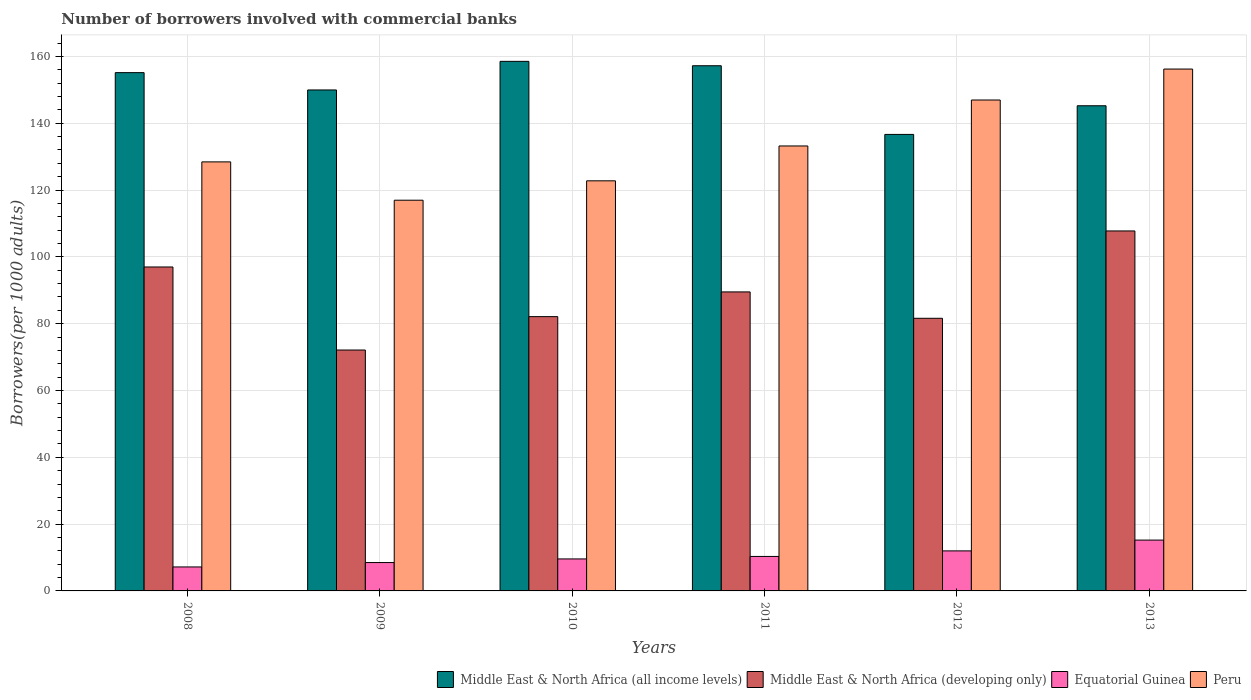How many groups of bars are there?
Ensure brevity in your answer.  6. What is the number of borrowers involved with commercial banks in Peru in 2012?
Ensure brevity in your answer.  146.94. Across all years, what is the maximum number of borrowers involved with commercial banks in Peru?
Provide a succinct answer. 156.21. Across all years, what is the minimum number of borrowers involved with commercial banks in Middle East & North Africa (all income levels)?
Provide a short and direct response. 136.65. What is the total number of borrowers involved with commercial banks in Middle East & North Africa (all income levels) in the graph?
Your answer should be very brief. 902.66. What is the difference between the number of borrowers involved with commercial banks in Peru in 2009 and that in 2011?
Provide a succinct answer. -16.24. What is the difference between the number of borrowers involved with commercial banks in Peru in 2011 and the number of borrowers involved with commercial banks in Equatorial Guinea in 2012?
Provide a succinct answer. 121.2. What is the average number of borrowers involved with commercial banks in Equatorial Guinea per year?
Your response must be concise. 10.46. In the year 2013, what is the difference between the number of borrowers involved with commercial banks in Peru and number of borrowers involved with commercial banks in Middle East & North Africa (all income levels)?
Offer a terse response. 10.99. What is the ratio of the number of borrowers involved with commercial banks in Middle East & North Africa (developing only) in 2011 to that in 2012?
Offer a terse response. 1.1. Is the number of borrowers involved with commercial banks in Equatorial Guinea in 2011 less than that in 2012?
Keep it short and to the point. Yes. Is the difference between the number of borrowers involved with commercial banks in Peru in 2011 and 2013 greater than the difference between the number of borrowers involved with commercial banks in Middle East & North Africa (all income levels) in 2011 and 2013?
Ensure brevity in your answer.  No. What is the difference between the highest and the second highest number of borrowers involved with commercial banks in Peru?
Give a very brief answer. 9.27. What is the difference between the highest and the lowest number of borrowers involved with commercial banks in Peru?
Ensure brevity in your answer.  39.26. In how many years, is the number of borrowers involved with commercial banks in Peru greater than the average number of borrowers involved with commercial banks in Peru taken over all years?
Offer a terse response. 2. Is the sum of the number of borrowers involved with commercial banks in Middle East & North Africa (developing only) in 2009 and 2011 greater than the maximum number of borrowers involved with commercial banks in Middle East & North Africa (all income levels) across all years?
Offer a very short reply. Yes. Is it the case that in every year, the sum of the number of borrowers involved with commercial banks in Equatorial Guinea and number of borrowers involved with commercial banks in Middle East & North Africa (all income levels) is greater than the sum of number of borrowers involved with commercial banks in Middle East & North Africa (developing only) and number of borrowers involved with commercial banks in Peru?
Your response must be concise. No. What does the 2nd bar from the left in 2010 represents?
Your response must be concise. Middle East & North Africa (developing only). What does the 3rd bar from the right in 2009 represents?
Your answer should be very brief. Middle East & North Africa (developing only). How many bars are there?
Provide a succinct answer. 24. How many years are there in the graph?
Your answer should be compact. 6. What is the difference between two consecutive major ticks on the Y-axis?
Give a very brief answer. 20. Are the values on the major ticks of Y-axis written in scientific E-notation?
Your response must be concise. No. Does the graph contain any zero values?
Give a very brief answer. No. How many legend labels are there?
Ensure brevity in your answer.  4. What is the title of the graph?
Keep it short and to the point. Number of borrowers involved with commercial banks. Does "Liechtenstein" appear as one of the legend labels in the graph?
Make the answer very short. No. What is the label or title of the Y-axis?
Your response must be concise. Borrowers(per 1000 adults). What is the Borrowers(per 1000 adults) of Middle East & North Africa (all income levels) in 2008?
Offer a very short reply. 155.14. What is the Borrowers(per 1000 adults) in Middle East & North Africa (developing only) in 2008?
Make the answer very short. 96.96. What is the Borrowers(per 1000 adults) in Equatorial Guinea in 2008?
Offer a very short reply. 7.17. What is the Borrowers(per 1000 adults) in Peru in 2008?
Make the answer very short. 128.42. What is the Borrowers(per 1000 adults) in Middle East & North Africa (all income levels) in 2009?
Your answer should be compact. 149.95. What is the Borrowers(per 1000 adults) of Middle East & North Africa (developing only) in 2009?
Your answer should be very brief. 72.11. What is the Borrowers(per 1000 adults) in Equatorial Guinea in 2009?
Your response must be concise. 8.49. What is the Borrowers(per 1000 adults) of Peru in 2009?
Give a very brief answer. 116.95. What is the Borrowers(per 1000 adults) of Middle East & North Africa (all income levels) in 2010?
Your response must be concise. 158.51. What is the Borrowers(per 1000 adults) of Middle East & North Africa (developing only) in 2010?
Provide a short and direct response. 82.1. What is the Borrowers(per 1000 adults) in Equatorial Guinea in 2010?
Provide a succinct answer. 9.58. What is the Borrowers(per 1000 adults) of Peru in 2010?
Provide a succinct answer. 122.75. What is the Borrowers(per 1000 adults) of Middle East & North Africa (all income levels) in 2011?
Give a very brief answer. 157.2. What is the Borrowers(per 1000 adults) in Middle East & North Africa (developing only) in 2011?
Your answer should be very brief. 89.5. What is the Borrowers(per 1000 adults) of Equatorial Guinea in 2011?
Your answer should be compact. 10.32. What is the Borrowers(per 1000 adults) of Peru in 2011?
Give a very brief answer. 133.19. What is the Borrowers(per 1000 adults) of Middle East & North Africa (all income levels) in 2012?
Provide a short and direct response. 136.65. What is the Borrowers(per 1000 adults) in Middle East & North Africa (developing only) in 2012?
Offer a very short reply. 81.61. What is the Borrowers(per 1000 adults) in Equatorial Guinea in 2012?
Your response must be concise. 11.98. What is the Borrowers(per 1000 adults) in Peru in 2012?
Your answer should be very brief. 146.94. What is the Borrowers(per 1000 adults) of Middle East & North Africa (all income levels) in 2013?
Provide a short and direct response. 145.22. What is the Borrowers(per 1000 adults) of Middle East & North Africa (developing only) in 2013?
Keep it short and to the point. 107.75. What is the Borrowers(per 1000 adults) in Equatorial Guinea in 2013?
Give a very brief answer. 15.22. What is the Borrowers(per 1000 adults) of Peru in 2013?
Provide a short and direct response. 156.21. Across all years, what is the maximum Borrowers(per 1000 adults) of Middle East & North Africa (all income levels)?
Give a very brief answer. 158.51. Across all years, what is the maximum Borrowers(per 1000 adults) in Middle East & North Africa (developing only)?
Your answer should be very brief. 107.75. Across all years, what is the maximum Borrowers(per 1000 adults) in Equatorial Guinea?
Make the answer very short. 15.22. Across all years, what is the maximum Borrowers(per 1000 adults) of Peru?
Your response must be concise. 156.21. Across all years, what is the minimum Borrowers(per 1000 adults) of Middle East & North Africa (all income levels)?
Provide a succinct answer. 136.65. Across all years, what is the minimum Borrowers(per 1000 adults) of Middle East & North Africa (developing only)?
Provide a short and direct response. 72.11. Across all years, what is the minimum Borrowers(per 1000 adults) of Equatorial Guinea?
Your answer should be compact. 7.17. Across all years, what is the minimum Borrowers(per 1000 adults) of Peru?
Offer a very short reply. 116.95. What is the total Borrowers(per 1000 adults) in Middle East & North Africa (all income levels) in the graph?
Ensure brevity in your answer.  902.66. What is the total Borrowers(per 1000 adults) in Middle East & North Africa (developing only) in the graph?
Offer a terse response. 530.03. What is the total Borrowers(per 1000 adults) in Equatorial Guinea in the graph?
Offer a terse response. 62.76. What is the total Borrowers(per 1000 adults) of Peru in the graph?
Offer a very short reply. 804.46. What is the difference between the Borrowers(per 1000 adults) in Middle East & North Africa (all income levels) in 2008 and that in 2009?
Your answer should be compact. 5.19. What is the difference between the Borrowers(per 1000 adults) of Middle East & North Africa (developing only) in 2008 and that in 2009?
Your answer should be very brief. 24.86. What is the difference between the Borrowers(per 1000 adults) of Equatorial Guinea in 2008 and that in 2009?
Give a very brief answer. -1.31. What is the difference between the Borrowers(per 1000 adults) in Peru in 2008 and that in 2009?
Your answer should be compact. 11.47. What is the difference between the Borrowers(per 1000 adults) in Middle East & North Africa (all income levels) in 2008 and that in 2010?
Keep it short and to the point. -3.38. What is the difference between the Borrowers(per 1000 adults) in Middle East & North Africa (developing only) in 2008 and that in 2010?
Give a very brief answer. 14.86. What is the difference between the Borrowers(per 1000 adults) of Equatorial Guinea in 2008 and that in 2010?
Provide a succinct answer. -2.4. What is the difference between the Borrowers(per 1000 adults) in Peru in 2008 and that in 2010?
Offer a terse response. 5.67. What is the difference between the Borrowers(per 1000 adults) in Middle East & North Africa (all income levels) in 2008 and that in 2011?
Your response must be concise. -2.06. What is the difference between the Borrowers(per 1000 adults) in Middle East & North Africa (developing only) in 2008 and that in 2011?
Your answer should be very brief. 7.46. What is the difference between the Borrowers(per 1000 adults) in Equatorial Guinea in 2008 and that in 2011?
Offer a very short reply. -3.14. What is the difference between the Borrowers(per 1000 adults) of Peru in 2008 and that in 2011?
Your answer should be compact. -4.77. What is the difference between the Borrowers(per 1000 adults) in Middle East & North Africa (all income levels) in 2008 and that in 2012?
Give a very brief answer. 18.49. What is the difference between the Borrowers(per 1000 adults) in Middle East & North Africa (developing only) in 2008 and that in 2012?
Keep it short and to the point. 15.36. What is the difference between the Borrowers(per 1000 adults) in Equatorial Guinea in 2008 and that in 2012?
Provide a short and direct response. -4.81. What is the difference between the Borrowers(per 1000 adults) of Peru in 2008 and that in 2012?
Make the answer very short. -18.52. What is the difference between the Borrowers(per 1000 adults) of Middle East & North Africa (all income levels) in 2008 and that in 2013?
Give a very brief answer. 9.91. What is the difference between the Borrowers(per 1000 adults) of Middle East & North Africa (developing only) in 2008 and that in 2013?
Keep it short and to the point. -10.79. What is the difference between the Borrowers(per 1000 adults) in Equatorial Guinea in 2008 and that in 2013?
Give a very brief answer. -8.04. What is the difference between the Borrowers(per 1000 adults) in Peru in 2008 and that in 2013?
Make the answer very short. -27.79. What is the difference between the Borrowers(per 1000 adults) of Middle East & North Africa (all income levels) in 2009 and that in 2010?
Offer a very short reply. -8.56. What is the difference between the Borrowers(per 1000 adults) in Middle East & North Africa (developing only) in 2009 and that in 2010?
Your answer should be very brief. -10. What is the difference between the Borrowers(per 1000 adults) of Equatorial Guinea in 2009 and that in 2010?
Your answer should be compact. -1.09. What is the difference between the Borrowers(per 1000 adults) of Peru in 2009 and that in 2010?
Make the answer very short. -5.8. What is the difference between the Borrowers(per 1000 adults) in Middle East & North Africa (all income levels) in 2009 and that in 2011?
Your response must be concise. -7.25. What is the difference between the Borrowers(per 1000 adults) in Middle East & North Africa (developing only) in 2009 and that in 2011?
Keep it short and to the point. -17.4. What is the difference between the Borrowers(per 1000 adults) of Equatorial Guinea in 2009 and that in 2011?
Your response must be concise. -1.83. What is the difference between the Borrowers(per 1000 adults) of Peru in 2009 and that in 2011?
Provide a succinct answer. -16.24. What is the difference between the Borrowers(per 1000 adults) in Middle East & North Africa (all income levels) in 2009 and that in 2012?
Keep it short and to the point. 13.3. What is the difference between the Borrowers(per 1000 adults) of Middle East & North Africa (developing only) in 2009 and that in 2012?
Ensure brevity in your answer.  -9.5. What is the difference between the Borrowers(per 1000 adults) of Equatorial Guinea in 2009 and that in 2012?
Provide a short and direct response. -3.5. What is the difference between the Borrowers(per 1000 adults) in Peru in 2009 and that in 2012?
Your answer should be compact. -29.99. What is the difference between the Borrowers(per 1000 adults) of Middle East & North Africa (all income levels) in 2009 and that in 2013?
Give a very brief answer. 4.73. What is the difference between the Borrowers(per 1000 adults) of Middle East & North Africa (developing only) in 2009 and that in 2013?
Keep it short and to the point. -35.65. What is the difference between the Borrowers(per 1000 adults) of Equatorial Guinea in 2009 and that in 2013?
Ensure brevity in your answer.  -6.73. What is the difference between the Borrowers(per 1000 adults) in Peru in 2009 and that in 2013?
Give a very brief answer. -39.26. What is the difference between the Borrowers(per 1000 adults) of Middle East & North Africa (all income levels) in 2010 and that in 2011?
Make the answer very short. 1.32. What is the difference between the Borrowers(per 1000 adults) in Middle East & North Africa (developing only) in 2010 and that in 2011?
Make the answer very short. -7.4. What is the difference between the Borrowers(per 1000 adults) of Equatorial Guinea in 2010 and that in 2011?
Your answer should be compact. -0.74. What is the difference between the Borrowers(per 1000 adults) in Peru in 2010 and that in 2011?
Ensure brevity in your answer.  -10.43. What is the difference between the Borrowers(per 1000 adults) of Middle East & North Africa (all income levels) in 2010 and that in 2012?
Offer a very short reply. 21.87. What is the difference between the Borrowers(per 1000 adults) in Middle East & North Africa (developing only) in 2010 and that in 2012?
Give a very brief answer. 0.5. What is the difference between the Borrowers(per 1000 adults) of Equatorial Guinea in 2010 and that in 2012?
Offer a terse response. -2.41. What is the difference between the Borrowers(per 1000 adults) of Peru in 2010 and that in 2012?
Your answer should be compact. -24.19. What is the difference between the Borrowers(per 1000 adults) of Middle East & North Africa (all income levels) in 2010 and that in 2013?
Make the answer very short. 13.29. What is the difference between the Borrowers(per 1000 adults) of Middle East & North Africa (developing only) in 2010 and that in 2013?
Offer a terse response. -25.65. What is the difference between the Borrowers(per 1000 adults) of Equatorial Guinea in 2010 and that in 2013?
Make the answer very short. -5.64. What is the difference between the Borrowers(per 1000 adults) in Peru in 2010 and that in 2013?
Your answer should be very brief. -33.46. What is the difference between the Borrowers(per 1000 adults) in Middle East & North Africa (all income levels) in 2011 and that in 2012?
Your response must be concise. 20.55. What is the difference between the Borrowers(per 1000 adults) of Middle East & North Africa (developing only) in 2011 and that in 2012?
Make the answer very short. 7.9. What is the difference between the Borrowers(per 1000 adults) of Equatorial Guinea in 2011 and that in 2012?
Your answer should be very brief. -1.67. What is the difference between the Borrowers(per 1000 adults) in Peru in 2011 and that in 2012?
Your answer should be very brief. -13.75. What is the difference between the Borrowers(per 1000 adults) in Middle East & North Africa (all income levels) in 2011 and that in 2013?
Offer a very short reply. 11.98. What is the difference between the Borrowers(per 1000 adults) of Middle East & North Africa (developing only) in 2011 and that in 2013?
Make the answer very short. -18.25. What is the difference between the Borrowers(per 1000 adults) in Equatorial Guinea in 2011 and that in 2013?
Your response must be concise. -4.9. What is the difference between the Borrowers(per 1000 adults) of Peru in 2011 and that in 2013?
Your answer should be very brief. -23.02. What is the difference between the Borrowers(per 1000 adults) in Middle East & North Africa (all income levels) in 2012 and that in 2013?
Ensure brevity in your answer.  -8.58. What is the difference between the Borrowers(per 1000 adults) of Middle East & North Africa (developing only) in 2012 and that in 2013?
Provide a short and direct response. -26.15. What is the difference between the Borrowers(per 1000 adults) in Equatorial Guinea in 2012 and that in 2013?
Keep it short and to the point. -3.23. What is the difference between the Borrowers(per 1000 adults) in Peru in 2012 and that in 2013?
Offer a very short reply. -9.27. What is the difference between the Borrowers(per 1000 adults) in Middle East & North Africa (all income levels) in 2008 and the Borrowers(per 1000 adults) in Middle East & North Africa (developing only) in 2009?
Offer a terse response. 83.03. What is the difference between the Borrowers(per 1000 adults) in Middle East & North Africa (all income levels) in 2008 and the Borrowers(per 1000 adults) in Equatorial Guinea in 2009?
Ensure brevity in your answer.  146.65. What is the difference between the Borrowers(per 1000 adults) of Middle East & North Africa (all income levels) in 2008 and the Borrowers(per 1000 adults) of Peru in 2009?
Offer a terse response. 38.18. What is the difference between the Borrowers(per 1000 adults) in Middle East & North Africa (developing only) in 2008 and the Borrowers(per 1000 adults) in Equatorial Guinea in 2009?
Make the answer very short. 88.47. What is the difference between the Borrowers(per 1000 adults) in Middle East & North Africa (developing only) in 2008 and the Borrowers(per 1000 adults) in Peru in 2009?
Make the answer very short. -19.99. What is the difference between the Borrowers(per 1000 adults) of Equatorial Guinea in 2008 and the Borrowers(per 1000 adults) of Peru in 2009?
Provide a succinct answer. -109.78. What is the difference between the Borrowers(per 1000 adults) of Middle East & North Africa (all income levels) in 2008 and the Borrowers(per 1000 adults) of Middle East & North Africa (developing only) in 2010?
Provide a short and direct response. 73.03. What is the difference between the Borrowers(per 1000 adults) of Middle East & North Africa (all income levels) in 2008 and the Borrowers(per 1000 adults) of Equatorial Guinea in 2010?
Provide a succinct answer. 145.56. What is the difference between the Borrowers(per 1000 adults) of Middle East & North Africa (all income levels) in 2008 and the Borrowers(per 1000 adults) of Peru in 2010?
Give a very brief answer. 32.38. What is the difference between the Borrowers(per 1000 adults) in Middle East & North Africa (developing only) in 2008 and the Borrowers(per 1000 adults) in Equatorial Guinea in 2010?
Keep it short and to the point. 87.39. What is the difference between the Borrowers(per 1000 adults) in Middle East & North Africa (developing only) in 2008 and the Borrowers(per 1000 adults) in Peru in 2010?
Make the answer very short. -25.79. What is the difference between the Borrowers(per 1000 adults) in Equatorial Guinea in 2008 and the Borrowers(per 1000 adults) in Peru in 2010?
Your response must be concise. -115.58. What is the difference between the Borrowers(per 1000 adults) in Middle East & North Africa (all income levels) in 2008 and the Borrowers(per 1000 adults) in Middle East & North Africa (developing only) in 2011?
Make the answer very short. 65.63. What is the difference between the Borrowers(per 1000 adults) of Middle East & North Africa (all income levels) in 2008 and the Borrowers(per 1000 adults) of Equatorial Guinea in 2011?
Keep it short and to the point. 144.82. What is the difference between the Borrowers(per 1000 adults) in Middle East & North Africa (all income levels) in 2008 and the Borrowers(per 1000 adults) in Peru in 2011?
Your answer should be compact. 21.95. What is the difference between the Borrowers(per 1000 adults) in Middle East & North Africa (developing only) in 2008 and the Borrowers(per 1000 adults) in Equatorial Guinea in 2011?
Your response must be concise. 86.65. What is the difference between the Borrowers(per 1000 adults) in Middle East & North Africa (developing only) in 2008 and the Borrowers(per 1000 adults) in Peru in 2011?
Your response must be concise. -36.22. What is the difference between the Borrowers(per 1000 adults) of Equatorial Guinea in 2008 and the Borrowers(per 1000 adults) of Peru in 2011?
Give a very brief answer. -126.01. What is the difference between the Borrowers(per 1000 adults) in Middle East & North Africa (all income levels) in 2008 and the Borrowers(per 1000 adults) in Middle East & North Africa (developing only) in 2012?
Make the answer very short. 73.53. What is the difference between the Borrowers(per 1000 adults) in Middle East & North Africa (all income levels) in 2008 and the Borrowers(per 1000 adults) in Equatorial Guinea in 2012?
Your answer should be very brief. 143.15. What is the difference between the Borrowers(per 1000 adults) of Middle East & North Africa (all income levels) in 2008 and the Borrowers(per 1000 adults) of Peru in 2012?
Keep it short and to the point. 8.19. What is the difference between the Borrowers(per 1000 adults) of Middle East & North Africa (developing only) in 2008 and the Borrowers(per 1000 adults) of Equatorial Guinea in 2012?
Offer a very short reply. 84.98. What is the difference between the Borrowers(per 1000 adults) in Middle East & North Africa (developing only) in 2008 and the Borrowers(per 1000 adults) in Peru in 2012?
Make the answer very short. -49.98. What is the difference between the Borrowers(per 1000 adults) in Equatorial Guinea in 2008 and the Borrowers(per 1000 adults) in Peru in 2012?
Give a very brief answer. -139.77. What is the difference between the Borrowers(per 1000 adults) of Middle East & North Africa (all income levels) in 2008 and the Borrowers(per 1000 adults) of Middle East & North Africa (developing only) in 2013?
Provide a short and direct response. 47.38. What is the difference between the Borrowers(per 1000 adults) in Middle East & North Africa (all income levels) in 2008 and the Borrowers(per 1000 adults) in Equatorial Guinea in 2013?
Give a very brief answer. 139.92. What is the difference between the Borrowers(per 1000 adults) of Middle East & North Africa (all income levels) in 2008 and the Borrowers(per 1000 adults) of Peru in 2013?
Your response must be concise. -1.07. What is the difference between the Borrowers(per 1000 adults) of Middle East & North Africa (developing only) in 2008 and the Borrowers(per 1000 adults) of Equatorial Guinea in 2013?
Give a very brief answer. 81.75. What is the difference between the Borrowers(per 1000 adults) of Middle East & North Africa (developing only) in 2008 and the Borrowers(per 1000 adults) of Peru in 2013?
Give a very brief answer. -59.25. What is the difference between the Borrowers(per 1000 adults) of Equatorial Guinea in 2008 and the Borrowers(per 1000 adults) of Peru in 2013?
Your response must be concise. -149.04. What is the difference between the Borrowers(per 1000 adults) in Middle East & North Africa (all income levels) in 2009 and the Borrowers(per 1000 adults) in Middle East & North Africa (developing only) in 2010?
Offer a very short reply. 67.85. What is the difference between the Borrowers(per 1000 adults) in Middle East & North Africa (all income levels) in 2009 and the Borrowers(per 1000 adults) in Equatorial Guinea in 2010?
Your response must be concise. 140.37. What is the difference between the Borrowers(per 1000 adults) in Middle East & North Africa (all income levels) in 2009 and the Borrowers(per 1000 adults) in Peru in 2010?
Make the answer very short. 27.2. What is the difference between the Borrowers(per 1000 adults) of Middle East & North Africa (developing only) in 2009 and the Borrowers(per 1000 adults) of Equatorial Guinea in 2010?
Make the answer very short. 62.53. What is the difference between the Borrowers(per 1000 adults) of Middle East & North Africa (developing only) in 2009 and the Borrowers(per 1000 adults) of Peru in 2010?
Your answer should be very brief. -50.65. What is the difference between the Borrowers(per 1000 adults) in Equatorial Guinea in 2009 and the Borrowers(per 1000 adults) in Peru in 2010?
Ensure brevity in your answer.  -114.26. What is the difference between the Borrowers(per 1000 adults) of Middle East & North Africa (all income levels) in 2009 and the Borrowers(per 1000 adults) of Middle East & North Africa (developing only) in 2011?
Offer a terse response. 60.45. What is the difference between the Borrowers(per 1000 adults) of Middle East & North Africa (all income levels) in 2009 and the Borrowers(per 1000 adults) of Equatorial Guinea in 2011?
Provide a succinct answer. 139.63. What is the difference between the Borrowers(per 1000 adults) of Middle East & North Africa (all income levels) in 2009 and the Borrowers(per 1000 adults) of Peru in 2011?
Offer a very short reply. 16.76. What is the difference between the Borrowers(per 1000 adults) of Middle East & North Africa (developing only) in 2009 and the Borrowers(per 1000 adults) of Equatorial Guinea in 2011?
Make the answer very short. 61.79. What is the difference between the Borrowers(per 1000 adults) of Middle East & North Africa (developing only) in 2009 and the Borrowers(per 1000 adults) of Peru in 2011?
Ensure brevity in your answer.  -61.08. What is the difference between the Borrowers(per 1000 adults) in Equatorial Guinea in 2009 and the Borrowers(per 1000 adults) in Peru in 2011?
Your answer should be compact. -124.7. What is the difference between the Borrowers(per 1000 adults) in Middle East & North Africa (all income levels) in 2009 and the Borrowers(per 1000 adults) in Middle East & North Africa (developing only) in 2012?
Offer a very short reply. 68.34. What is the difference between the Borrowers(per 1000 adults) in Middle East & North Africa (all income levels) in 2009 and the Borrowers(per 1000 adults) in Equatorial Guinea in 2012?
Offer a very short reply. 137.96. What is the difference between the Borrowers(per 1000 adults) in Middle East & North Africa (all income levels) in 2009 and the Borrowers(per 1000 adults) in Peru in 2012?
Keep it short and to the point. 3.01. What is the difference between the Borrowers(per 1000 adults) of Middle East & North Africa (developing only) in 2009 and the Borrowers(per 1000 adults) of Equatorial Guinea in 2012?
Your answer should be very brief. 60.12. What is the difference between the Borrowers(per 1000 adults) of Middle East & North Africa (developing only) in 2009 and the Borrowers(per 1000 adults) of Peru in 2012?
Ensure brevity in your answer.  -74.84. What is the difference between the Borrowers(per 1000 adults) of Equatorial Guinea in 2009 and the Borrowers(per 1000 adults) of Peru in 2012?
Offer a terse response. -138.45. What is the difference between the Borrowers(per 1000 adults) in Middle East & North Africa (all income levels) in 2009 and the Borrowers(per 1000 adults) in Middle East & North Africa (developing only) in 2013?
Make the answer very short. 42.2. What is the difference between the Borrowers(per 1000 adults) of Middle East & North Africa (all income levels) in 2009 and the Borrowers(per 1000 adults) of Equatorial Guinea in 2013?
Offer a very short reply. 134.73. What is the difference between the Borrowers(per 1000 adults) of Middle East & North Africa (all income levels) in 2009 and the Borrowers(per 1000 adults) of Peru in 2013?
Offer a very short reply. -6.26. What is the difference between the Borrowers(per 1000 adults) in Middle East & North Africa (developing only) in 2009 and the Borrowers(per 1000 adults) in Equatorial Guinea in 2013?
Your answer should be very brief. 56.89. What is the difference between the Borrowers(per 1000 adults) in Middle East & North Africa (developing only) in 2009 and the Borrowers(per 1000 adults) in Peru in 2013?
Keep it short and to the point. -84.1. What is the difference between the Borrowers(per 1000 adults) in Equatorial Guinea in 2009 and the Borrowers(per 1000 adults) in Peru in 2013?
Your answer should be compact. -147.72. What is the difference between the Borrowers(per 1000 adults) of Middle East & North Africa (all income levels) in 2010 and the Borrowers(per 1000 adults) of Middle East & North Africa (developing only) in 2011?
Your answer should be very brief. 69.01. What is the difference between the Borrowers(per 1000 adults) of Middle East & North Africa (all income levels) in 2010 and the Borrowers(per 1000 adults) of Equatorial Guinea in 2011?
Your answer should be very brief. 148.2. What is the difference between the Borrowers(per 1000 adults) of Middle East & North Africa (all income levels) in 2010 and the Borrowers(per 1000 adults) of Peru in 2011?
Your answer should be very brief. 25.33. What is the difference between the Borrowers(per 1000 adults) of Middle East & North Africa (developing only) in 2010 and the Borrowers(per 1000 adults) of Equatorial Guinea in 2011?
Ensure brevity in your answer.  71.78. What is the difference between the Borrowers(per 1000 adults) of Middle East & North Africa (developing only) in 2010 and the Borrowers(per 1000 adults) of Peru in 2011?
Give a very brief answer. -51.09. What is the difference between the Borrowers(per 1000 adults) in Equatorial Guinea in 2010 and the Borrowers(per 1000 adults) in Peru in 2011?
Provide a short and direct response. -123.61. What is the difference between the Borrowers(per 1000 adults) of Middle East & North Africa (all income levels) in 2010 and the Borrowers(per 1000 adults) of Middle East & North Africa (developing only) in 2012?
Your response must be concise. 76.91. What is the difference between the Borrowers(per 1000 adults) in Middle East & North Africa (all income levels) in 2010 and the Borrowers(per 1000 adults) in Equatorial Guinea in 2012?
Your response must be concise. 146.53. What is the difference between the Borrowers(per 1000 adults) in Middle East & North Africa (all income levels) in 2010 and the Borrowers(per 1000 adults) in Peru in 2012?
Provide a short and direct response. 11.57. What is the difference between the Borrowers(per 1000 adults) in Middle East & North Africa (developing only) in 2010 and the Borrowers(per 1000 adults) in Equatorial Guinea in 2012?
Your answer should be compact. 70.12. What is the difference between the Borrowers(per 1000 adults) in Middle East & North Africa (developing only) in 2010 and the Borrowers(per 1000 adults) in Peru in 2012?
Offer a terse response. -64.84. What is the difference between the Borrowers(per 1000 adults) in Equatorial Guinea in 2010 and the Borrowers(per 1000 adults) in Peru in 2012?
Give a very brief answer. -137.36. What is the difference between the Borrowers(per 1000 adults) of Middle East & North Africa (all income levels) in 2010 and the Borrowers(per 1000 adults) of Middle East & North Africa (developing only) in 2013?
Offer a terse response. 50.76. What is the difference between the Borrowers(per 1000 adults) in Middle East & North Africa (all income levels) in 2010 and the Borrowers(per 1000 adults) in Equatorial Guinea in 2013?
Provide a succinct answer. 143.3. What is the difference between the Borrowers(per 1000 adults) of Middle East & North Africa (all income levels) in 2010 and the Borrowers(per 1000 adults) of Peru in 2013?
Offer a terse response. 2.3. What is the difference between the Borrowers(per 1000 adults) in Middle East & North Africa (developing only) in 2010 and the Borrowers(per 1000 adults) in Equatorial Guinea in 2013?
Provide a succinct answer. 66.89. What is the difference between the Borrowers(per 1000 adults) in Middle East & North Africa (developing only) in 2010 and the Borrowers(per 1000 adults) in Peru in 2013?
Provide a succinct answer. -74.11. What is the difference between the Borrowers(per 1000 adults) in Equatorial Guinea in 2010 and the Borrowers(per 1000 adults) in Peru in 2013?
Keep it short and to the point. -146.63. What is the difference between the Borrowers(per 1000 adults) of Middle East & North Africa (all income levels) in 2011 and the Borrowers(per 1000 adults) of Middle East & North Africa (developing only) in 2012?
Ensure brevity in your answer.  75.59. What is the difference between the Borrowers(per 1000 adults) of Middle East & North Africa (all income levels) in 2011 and the Borrowers(per 1000 adults) of Equatorial Guinea in 2012?
Offer a terse response. 145.21. What is the difference between the Borrowers(per 1000 adults) in Middle East & North Africa (all income levels) in 2011 and the Borrowers(per 1000 adults) in Peru in 2012?
Ensure brevity in your answer.  10.26. What is the difference between the Borrowers(per 1000 adults) of Middle East & North Africa (developing only) in 2011 and the Borrowers(per 1000 adults) of Equatorial Guinea in 2012?
Offer a very short reply. 77.52. What is the difference between the Borrowers(per 1000 adults) in Middle East & North Africa (developing only) in 2011 and the Borrowers(per 1000 adults) in Peru in 2012?
Provide a succinct answer. -57.44. What is the difference between the Borrowers(per 1000 adults) in Equatorial Guinea in 2011 and the Borrowers(per 1000 adults) in Peru in 2012?
Offer a very short reply. -136.62. What is the difference between the Borrowers(per 1000 adults) in Middle East & North Africa (all income levels) in 2011 and the Borrowers(per 1000 adults) in Middle East & North Africa (developing only) in 2013?
Give a very brief answer. 49.45. What is the difference between the Borrowers(per 1000 adults) of Middle East & North Africa (all income levels) in 2011 and the Borrowers(per 1000 adults) of Equatorial Guinea in 2013?
Keep it short and to the point. 141.98. What is the difference between the Borrowers(per 1000 adults) of Middle East & North Africa (all income levels) in 2011 and the Borrowers(per 1000 adults) of Peru in 2013?
Your response must be concise. 0.99. What is the difference between the Borrowers(per 1000 adults) in Middle East & North Africa (developing only) in 2011 and the Borrowers(per 1000 adults) in Equatorial Guinea in 2013?
Your answer should be compact. 74.29. What is the difference between the Borrowers(per 1000 adults) of Middle East & North Africa (developing only) in 2011 and the Borrowers(per 1000 adults) of Peru in 2013?
Keep it short and to the point. -66.71. What is the difference between the Borrowers(per 1000 adults) of Equatorial Guinea in 2011 and the Borrowers(per 1000 adults) of Peru in 2013?
Your answer should be very brief. -145.89. What is the difference between the Borrowers(per 1000 adults) of Middle East & North Africa (all income levels) in 2012 and the Borrowers(per 1000 adults) of Middle East & North Africa (developing only) in 2013?
Ensure brevity in your answer.  28.89. What is the difference between the Borrowers(per 1000 adults) in Middle East & North Africa (all income levels) in 2012 and the Borrowers(per 1000 adults) in Equatorial Guinea in 2013?
Offer a very short reply. 121.43. What is the difference between the Borrowers(per 1000 adults) in Middle East & North Africa (all income levels) in 2012 and the Borrowers(per 1000 adults) in Peru in 2013?
Provide a succinct answer. -19.56. What is the difference between the Borrowers(per 1000 adults) in Middle East & North Africa (developing only) in 2012 and the Borrowers(per 1000 adults) in Equatorial Guinea in 2013?
Your answer should be compact. 66.39. What is the difference between the Borrowers(per 1000 adults) of Middle East & North Africa (developing only) in 2012 and the Borrowers(per 1000 adults) of Peru in 2013?
Your response must be concise. -74.6. What is the difference between the Borrowers(per 1000 adults) of Equatorial Guinea in 2012 and the Borrowers(per 1000 adults) of Peru in 2013?
Provide a short and direct response. -144.23. What is the average Borrowers(per 1000 adults) of Middle East & North Africa (all income levels) per year?
Offer a very short reply. 150.44. What is the average Borrowers(per 1000 adults) of Middle East & North Africa (developing only) per year?
Keep it short and to the point. 88.34. What is the average Borrowers(per 1000 adults) of Equatorial Guinea per year?
Give a very brief answer. 10.46. What is the average Borrowers(per 1000 adults) of Peru per year?
Provide a succinct answer. 134.08. In the year 2008, what is the difference between the Borrowers(per 1000 adults) of Middle East & North Africa (all income levels) and Borrowers(per 1000 adults) of Middle East & North Africa (developing only)?
Your answer should be very brief. 58.17. In the year 2008, what is the difference between the Borrowers(per 1000 adults) in Middle East & North Africa (all income levels) and Borrowers(per 1000 adults) in Equatorial Guinea?
Keep it short and to the point. 147.96. In the year 2008, what is the difference between the Borrowers(per 1000 adults) in Middle East & North Africa (all income levels) and Borrowers(per 1000 adults) in Peru?
Your answer should be compact. 26.71. In the year 2008, what is the difference between the Borrowers(per 1000 adults) of Middle East & North Africa (developing only) and Borrowers(per 1000 adults) of Equatorial Guinea?
Provide a short and direct response. 89.79. In the year 2008, what is the difference between the Borrowers(per 1000 adults) of Middle East & North Africa (developing only) and Borrowers(per 1000 adults) of Peru?
Your answer should be compact. -31.46. In the year 2008, what is the difference between the Borrowers(per 1000 adults) of Equatorial Guinea and Borrowers(per 1000 adults) of Peru?
Your response must be concise. -121.25. In the year 2009, what is the difference between the Borrowers(per 1000 adults) in Middle East & North Africa (all income levels) and Borrowers(per 1000 adults) in Middle East & North Africa (developing only)?
Your response must be concise. 77.84. In the year 2009, what is the difference between the Borrowers(per 1000 adults) in Middle East & North Africa (all income levels) and Borrowers(per 1000 adults) in Equatorial Guinea?
Ensure brevity in your answer.  141.46. In the year 2009, what is the difference between the Borrowers(per 1000 adults) of Middle East & North Africa (all income levels) and Borrowers(per 1000 adults) of Peru?
Give a very brief answer. 33. In the year 2009, what is the difference between the Borrowers(per 1000 adults) in Middle East & North Africa (developing only) and Borrowers(per 1000 adults) in Equatorial Guinea?
Provide a succinct answer. 63.62. In the year 2009, what is the difference between the Borrowers(per 1000 adults) in Middle East & North Africa (developing only) and Borrowers(per 1000 adults) in Peru?
Make the answer very short. -44.85. In the year 2009, what is the difference between the Borrowers(per 1000 adults) in Equatorial Guinea and Borrowers(per 1000 adults) in Peru?
Your answer should be very brief. -108.46. In the year 2010, what is the difference between the Borrowers(per 1000 adults) in Middle East & North Africa (all income levels) and Borrowers(per 1000 adults) in Middle East & North Africa (developing only)?
Keep it short and to the point. 76.41. In the year 2010, what is the difference between the Borrowers(per 1000 adults) in Middle East & North Africa (all income levels) and Borrowers(per 1000 adults) in Equatorial Guinea?
Provide a succinct answer. 148.94. In the year 2010, what is the difference between the Borrowers(per 1000 adults) in Middle East & North Africa (all income levels) and Borrowers(per 1000 adults) in Peru?
Offer a very short reply. 35.76. In the year 2010, what is the difference between the Borrowers(per 1000 adults) of Middle East & North Africa (developing only) and Borrowers(per 1000 adults) of Equatorial Guinea?
Keep it short and to the point. 72.52. In the year 2010, what is the difference between the Borrowers(per 1000 adults) of Middle East & North Africa (developing only) and Borrowers(per 1000 adults) of Peru?
Your answer should be very brief. -40.65. In the year 2010, what is the difference between the Borrowers(per 1000 adults) of Equatorial Guinea and Borrowers(per 1000 adults) of Peru?
Your response must be concise. -113.18. In the year 2011, what is the difference between the Borrowers(per 1000 adults) in Middle East & North Africa (all income levels) and Borrowers(per 1000 adults) in Middle East & North Africa (developing only)?
Offer a very short reply. 67.7. In the year 2011, what is the difference between the Borrowers(per 1000 adults) in Middle East & North Africa (all income levels) and Borrowers(per 1000 adults) in Equatorial Guinea?
Your answer should be compact. 146.88. In the year 2011, what is the difference between the Borrowers(per 1000 adults) of Middle East & North Africa (all income levels) and Borrowers(per 1000 adults) of Peru?
Provide a short and direct response. 24.01. In the year 2011, what is the difference between the Borrowers(per 1000 adults) in Middle East & North Africa (developing only) and Borrowers(per 1000 adults) in Equatorial Guinea?
Your answer should be very brief. 79.18. In the year 2011, what is the difference between the Borrowers(per 1000 adults) of Middle East & North Africa (developing only) and Borrowers(per 1000 adults) of Peru?
Your answer should be very brief. -43.69. In the year 2011, what is the difference between the Borrowers(per 1000 adults) of Equatorial Guinea and Borrowers(per 1000 adults) of Peru?
Your answer should be compact. -122.87. In the year 2012, what is the difference between the Borrowers(per 1000 adults) in Middle East & North Africa (all income levels) and Borrowers(per 1000 adults) in Middle East & North Africa (developing only)?
Your response must be concise. 55.04. In the year 2012, what is the difference between the Borrowers(per 1000 adults) in Middle East & North Africa (all income levels) and Borrowers(per 1000 adults) in Equatorial Guinea?
Offer a very short reply. 124.66. In the year 2012, what is the difference between the Borrowers(per 1000 adults) in Middle East & North Africa (all income levels) and Borrowers(per 1000 adults) in Peru?
Ensure brevity in your answer.  -10.29. In the year 2012, what is the difference between the Borrowers(per 1000 adults) in Middle East & North Africa (developing only) and Borrowers(per 1000 adults) in Equatorial Guinea?
Provide a short and direct response. 69.62. In the year 2012, what is the difference between the Borrowers(per 1000 adults) in Middle East & North Africa (developing only) and Borrowers(per 1000 adults) in Peru?
Your answer should be compact. -65.34. In the year 2012, what is the difference between the Borrowers(per 1000 adults) in Equatorial Guinea and Borrowers(per 1000 adults) in Peru?
Give a very brief answer. -134.96. In the year 2013, what is the difference between the Borrowers(per 1000 adults) of Middle East & North Africa (all income levels) and Borrowers(per 1000 adults) of Middle East & North Africa (developing only)?
Make the answer very short. 37.47. In the year 2013, what is the difference between the Borrowers(per 1000 adults) in Middle East & North Africa (all income levels) and Borrowers(per 1000 adults) in Equatorial Guinea?
Your answer should be very brief. 130.01. In the year 2013, what is the difference between the Borrowers(per 1000 adults) in Middle East & North Africa (all income levels) and Borrowers(per 1000 adults) in Peru?
Provide a short and direct response. -10.99. In the year 2013, what is the difference between the Borrowers(per 1000 adults) of Middle East & North Africa (developing only) and Borrowers(per 1000 adults) of Equatorial Guinea?
Your answer should be very brief. 92.54. In the year 2013, what is the difference between the Borrowers(per 1000 adults) in Middle East & North Africa (developing only) and Borrowers(per 1000 adults) in Peru?
Your answer should be compact. -48.46. In the year 2013, what is the difference between the Borrowers(per 1000 adults) of Equatorial Guinea and Borrowers(per 1000 adults) of Peru?
Make the answer very short. -140.99. What is the ratio of the Borrowers(per 1000 adults) of Middle East & North Africa (all income levels) in 2008 to that in 2009?
Give a very brief answer. 1.03. What is the ratio of the Borrowers(per 1000 adults) of Middle East & North Africa (developing only) in 2008 to that in 2009?
Provide a succinct answer. 1.34. What is the ratio of the Borrowers(per 1000 adults) in Equatorial Guinea in 2008 to that in 2009?
Provide a short and direct response. 0.85. What is the ratio of the Borrowers(per 1000 adults) in Peru in 2008 to that in 2009?
Offer a terse response. 1.1. What is the ratio of the Borrowers(per 1000 adults) of Middle East & North Africa (all income levels) in 2008 to that in 2010?
Your answer should be very brief. 0.98. What is the ratio of the Borrowers(per 1000 adults) in Middle East & North Africa (developing only) in 2008 to that in 2010?
Offer a terse response. 1.18. What is the ratio of the Borrowers(per 1000 adults) of Equatorial Guinea in 2008 to that in 2010?
Make the answer very short. 0.75. What is the ratio of the Borrowers(per 1000 adults) of Peru in 2008 to that in 2010?
Offer a very short reply. 1.05. What is the ratio of the Borrowers(per 1000 adults) in Middle East & North Africa (all income levels) in 2008 to that in 2011?
Make the answer very short. 0.99. What is the ratio of the Borrowers(per 1000 adults) in Middle East & North Africa (developing only) in 2008 to that in 2011?
Your response must be concise. 1.08. What is the ratio of the Borrowers(per 1000 adults) in Equatorial Guinea in 2008 to that in 2011?
Provide a short and direct response. 0.7. What is the ratio of the Borrowers(per 1000 adults) in Peru in 2008 to that in 2011?
Make the answer very short. 0.96. What is the ratio of the Borrowers(per 1000 adults) in Middle East & North Africa (all income levels) in 2008 to that in 2012?
Provide a short and direct response. 1.14. What is the ratio of the Borrowers(per 1000 adults) in Middle East & North Africa (developing only) in 2008 to that in 2012?
Keep it short and to the point. 1.19. What is the ratio of the Borrowers(per 1000 adults) of Equatorial Guinea in 2008 to that in 2012?
Your answer should be compact. 0.6. What is the ratio of the Borrowers(per 1000 adults) in Peru in 2008 to that in 2012?
Keep it short and to the point. 0.87. What is the ratio of the Borrowers(per 1000 adults) of Middle East & North Africa (all income levels) in 2008 to that in 2013?
Provide a short and direct response. 1.07. What is the ratio of the Borrowers(per 1000 adults) in Middle East & North Africa (developing only) in 2008 to that in 2013?
Keep it short and to the point. 0.9. What is the ratio of the Borrowers(per 1000 adults) in Equatorial Guinea in 2008 to that in 2013?
Give a very brief answer. 0.47. What is the ratio of the Borrowers(per 1000 adults) in Peru in 2008 to that in 2013?
Provide a succinct answer. 0.82. What is the ratio of the Borrowers(per 1000 adults) in Middle East & North Africa (all income levels) in 2009 to that in 2010?
Make the answer very short. 0.95. What is the ratio of the Borrowers(per 1000 adults) in Middle East & North Africa (developing only) in 2009 to that in 2010?
Offer a terse response. 0.88. What is the ratio of the Borrowers(per 1000 adults) in Equatorial Guinea in 2009 to that in 2010?
Provide a short and direct response. 0.89. What is the ratio of the Borrowers(per 1000 adults) in Peru in 2009 to that in 2010?
Offer a very short reply. 0.95. What is the ratio of the Borrowers(per 1000 adults) of Middle East & North Africa (all income levels) in 2009 to that in 2011?
Give a very brief answer. 0.95. What is the ratio of the Borrowers(per 1000 adults) of Middle East & North Africa (developing only) in 2009 to that in 2011?
Your answer should be very brief. 0.81. What is the ratio of the Borrowers(per 1000 adults) of Equatorial Guinea in 2009 to that in 2011?
Give a very brief answer. 0.82. What is the ratio of the Borrowers(per 1000 adults) in Peru in 2009 to that in 2011?
Make the answer very short. 0.88. What is the ratio of the Borrowers(per 1000 adults) of Middle East & North Africa (all income levels) in 2009 to that in 2012?
Offer a terse response. 1.1. What is the ratio of the Borrowers(per 1000 adults) of Middle East & North Africa (developing only) in 2009 to that in 2012?
Offer a very short reply. 0.88. What is the ratio of the Borrowers(per 1000 adults) of Equatorial Guinea in 2009 to that in 2012?
Keep it short and to the point. 0.71. What is the ratio of the Borrowers(per 1000 adults) in Peru in 2009 to that in 2012?
Your answer should be very brief. 0.8. What is the ratio of the Borrowers(per 1000 adults) of Middle East & North Africa (all income levels) in 2009 to that in 2013?
Your response must be concise. 1.03. What is the ratio of the Borrowers(per 1000 adults) in Middle East & North Africa (developing only) in 2009 to that in 2013?
Keep it short and to the point. 0.67. What is the ratio of the Borrowers(per 1000 adults) of Equatorial Guinea in 2009 to that in 2013?
Offer a very short reply. 0.56. What is the ratio of the Borrowers(per 1000 adults) in Peru in 2009 to that in 2013?
Your answer should be very brief. 0.75. What is the ratio of the Borrowers(per 1000 adults) in Middle East & North Africa (all income levels) in 2010 to that in 2011?
Offer a terse response. 1.01. What is the ratio of the Borrowers(per 1000 adults) of Middle East & North Africa (developing only) in 2010 to that in 2011?
Give a very brief answer. 0.92. What is the ratio of the Borrowers(per 1000 adults) of Equatorial Guinea in 2010 to that in 2011?
Ensure brevity in your answer.  0.93. What is the ratio of the Borrowers(per 1000 adults) of Peru in 2010 to that in 2011?
Provide a short and direct response. 0.92. What is the ratio of the Borrowers(per 1000 adults) of Middle East & North Africa (all income levels) in 2010 to that in 2012?
Give a very brief answer. 1.16. What is the ratio of the Borrowers(per 1000 adults) in Equatorial Guinea in 2010 to that in 2012?
Ensure brevity in your answer.  0.8. What is the ratio of the Borrowers(per 1000 adults) of Peru in 2010 to that in 2012?
Give a very brief answer. 0.84. What is the ratio of the Borrowers(per 1000 adults) in Middle East & North Africa (all income levels) in 2010 to that in 2013?
Your response must be concise. 1.09. What is the ratio of the Borrowers(per 1000 adults) of Middle East & North Africa (developing only) in 2010 to that in 2013?
Your answer should be very brief. 0.76. What is the ratio of the Borrowers(per 1000 adults) of Equatorial Guinea in 2010 to that in 2013?
Your response must be concise. 0.63. What is the ratio of the Borrowers(per 1000 adults) of Peru in 2010 to that in 2013?
Give a very brief answer. 0.79. What is the ratio of the Borrowers(per 1000 adults) in Middle East & North Africa (all income levels) in 2011 to that in 2012?
Provide a short and direct response. 1.15. What is the ratio of the Borrowers(per 1000 adults) in Middle East & North Africa (developing only) in 2011 to that in 2012?
Ensure brevity in your answer.  1.1. What is the ratio of the Borrowers(per 1000 adults) of Equatorial Guinea in 2011 to that in 2012?
Your response must be concise. 0.86. What is the ratio of the Borrowers(per 1000 adults) of Peru in 2011 to that in 2012?
Offer a very short reply. 0.91. What is the ratio of the Borrowers(per 1000 adults) of Middle East & North Africa (all income levels) in 2011 to that in 2013?
Your answer should be very brief. 1.08. What is the ratio of the Borrowers(per 1000 adults) in Middle East & North Africa (developing only) in 2011 to that in 2013?
Offer a terse response. 0.83. What is the ratio of the Borrowers(per 1000 adults) in Equatorial Guinea in 2011 to that in 2013?
Provide a succinct answer. 0.68. What is the ratio of the Borrowers(per 1000 adults) of Peru in 2011 to that in 2013?
Give a very brief answer. 0.85. What is the ratio of the Borrowers(per 1000 adults) of Middle East & North Africa (all income levels) in 2012 to that in 2013?
Offer a very short reply. 0.94. What is the ratio of the Borrowers(per 1000 adults) in Middle East & North Africa (developing only) in 2012 to that in 2013?
Your answer should be compact. 0.76. What is the ratio of the Borrowers(per 1000 adults) of Equatorial Guinea in 2012 to that in 2013?
Make the answer very short. 0.79. What is the ratio of the Borrowers(per 1000 adults) in Peru in 2012 to that in 2013?
Offer a terse response. 0.94. What is the difference between the highest and the second highest Borrowers(per 1000 adults) of Middle East & North Africa (all income levels)?
Your response must be concise. 1.32. What is the difference between the highest and the second highest Borrowers(per 1000 adults) in Middle East & North Africa (developing only)?
Provide a succinct answer. 10.79. What is the difference between the highest and the second highest Borrowers(per 1000 adults) in Equatorial Guinea?
Provide a short and direct response. 3.23. What is the difference between the highest and the second highest Borrowers(per 1000 adults) of Peru?
Make the answer very short. 9.27. What is the difference between the highest and the lowest Borrowers(per 1000 adults) of Middle East & North Africa (all income levels)?
Keep it short and to the point. 21.87. What is the difference between the highest and the lowest Borrowers(per 1000 adults) in Middle East & North Africa (developing only)?
Provide a succinct answer. 35.65. What is the difference between the highest and the lowest Borrowers(per 1000 adults) of Equatorial Guinea?
Provide a short and direct response. 8.04. What is the difference between the highest and the lowest Borrowers(per 1000 adults) in Peru?
Your answer should be compact. 39.26. 